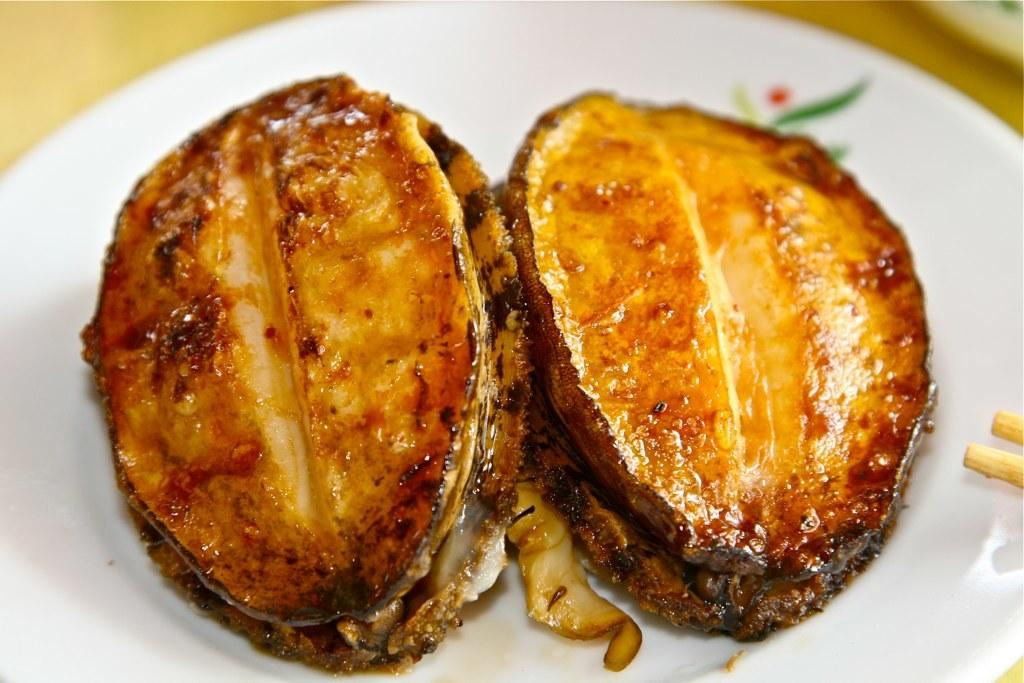What is on the plate that is visible in the image? There is a plate with food in the image. What color is the plate? The plate is white. What colors can be seen in the food on the plate? The food is in brown and black colors. What is the color of the surface the plate is on? The plate is on a brown surface. How many slaves are depicted in the image? There are no slaves depicted in the image; it features a plate with food on a brown surface. What type of insect can be seen crawling on the plate in the image? There are no insects present in the image; it features a plate with food on a brown surface. 